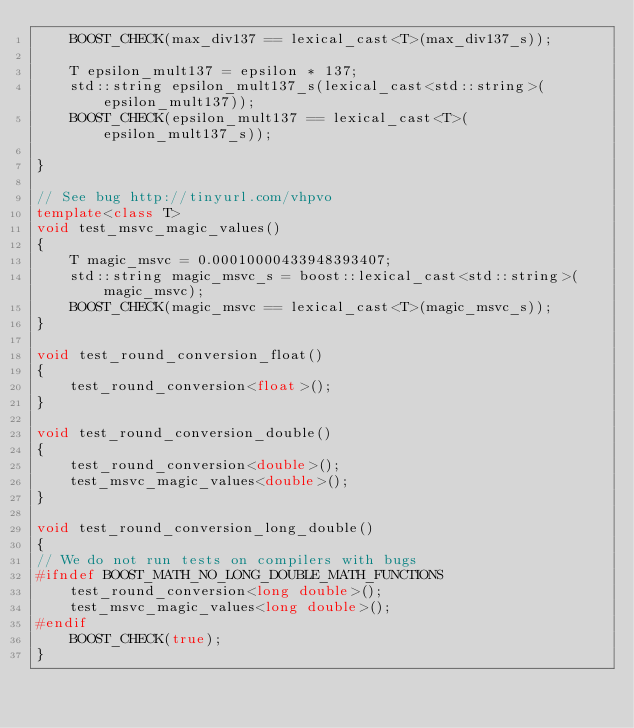Convert code to text. <code><loc_0><loc_0><loc_500><loc_500><_C++_>    BOOST_CHECK(max_div137 == lexical_cast<T>(max_div137_s));

    T epsilon_mult137 = epsilon * 137;
    std::string epsilon_mult137_s(lexical_cast<std::string>(epsilon_mult137));
    BOOST_CHECK(epsilon_mult137 == lexical_cast<T>(epsilon_mult137_s));

}

// See bug http://tinyurl.com/vhpvo
template<class T>
void test_msvc_magic_values()
{
    T magic_msvc = 0.00010000433948393407;
    std::string magic_msvc_s = boost::lexical_cast<std::string>(magic_msvc);
    BOOST_CHECK(magic_msvc == lexical_cast<T>(magic_msvc_s));
}

void test_round_conversion_float()
{
    test_round_conversion<float>();
}

void test_round_conversion_double()
{
    test_round_conversion<double>();
    test_msvc_magic_values<double>();
}

void test_round_conversion_long_double()
{
// We do not run tests on compilers with bugs
#ifndef BOOST_MATH_NO_LONG_DOUBLE_MATH_FUNCTIONS
    test_round_conversion<long double>();
    test_msvc_magic_values<long double>();
#endif
    BOOST_CHECK(true);
}

</code> 